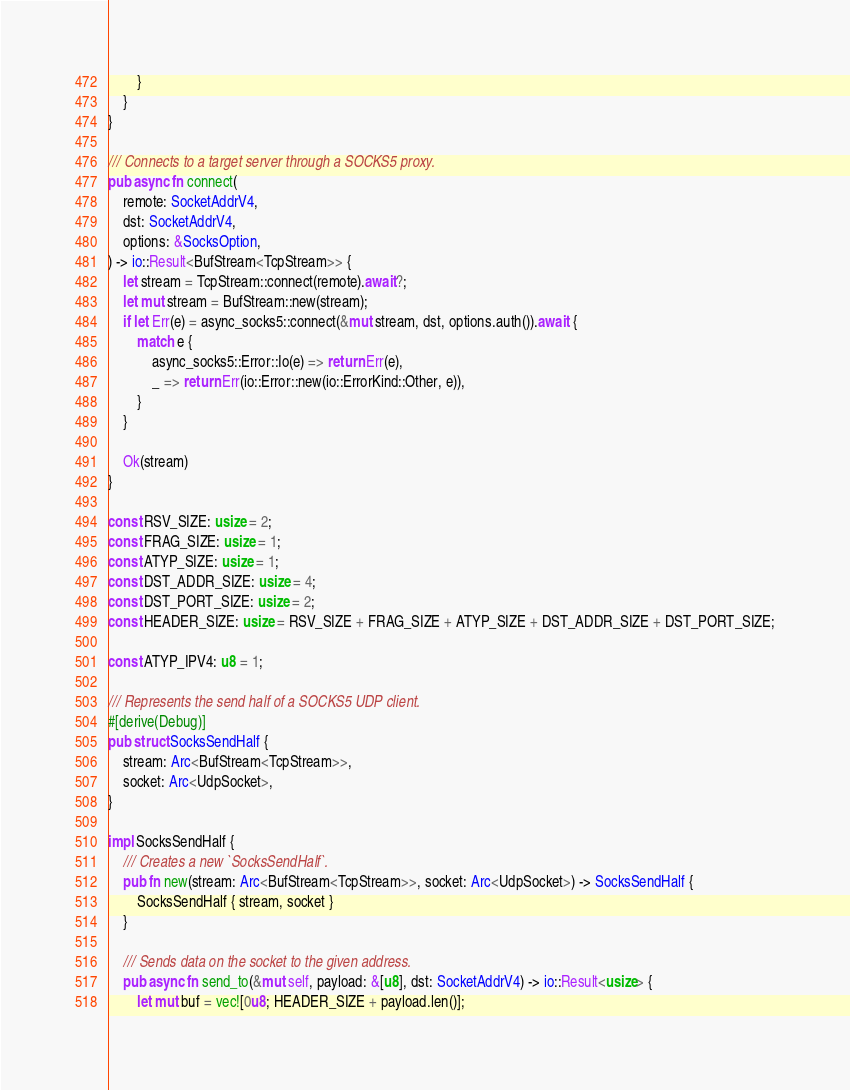Convert code to text. <code><loc_0><loc_0><loc_500><loc_500><_Rust_>        }
    }
}

/// Connects to a target server through a SOCKS5 proxy.
pub async fn connect(
    remote: SocketAddrV4,
    dst: SocketAddrV4,
    options: &SocksOption,
) -> io::Result<BufStream<TcpStream>> {
    let stream = TcpStream::connect(remote).await?;
    let mut stream = BufStream::new(stream);
    if let Err(e) = async_socks5::connect(&mut stream, dst, options.auth()).await {
        match e {
            async_socks5::Error::Io(e) => return Err(e),
            _ => return Err(io::Error::new(io::ErrorKind::Other, e)),
        }
    }

    Ok(stream)
}

const RSV_SIZE: usize = 2;
const FRAG_SIZE: usize = 1;
const ATYP_SIZE: usize = 1;
const DST_ADDR_SIZE: usize = 4;
const DST_PORT_SIZE: usize = 2;
const HEADER_SIZE: usize = RSV_SIZE + FRAG_SIZE + ATYP_SIZE + DST_ADDR_SIZE + DST_PORT_SIZE;

const ATYP_IPV4: u8 = 1;

/// Represents the send half of a SOCKS5 UDP client.
#[derive(Debug)]
pub struct SocksSendHalf {
    stream: Arc<BufStream<TcpStream>>,
    socket: Arc<UdpSocket>,
}

impl SocksSendHalf {
    /// Creates a new `SocksSendHalf`.
    pub fn new(stream: Arc<BufStream<TcpStream>>, socket: Arc<UdpSocket>) -> SocksSendHalf {
        SocksSendHalf { stream, socket }
    }

    /// Sends data on the socket to the given address.
    pub async fn send_to(&mut self, payload: &[u8], dst: SocketAddrV4) -> io::Result<usize> {
        let mut buf = vec![0u8; HEADER_SIZE + payload.len()];</code> 